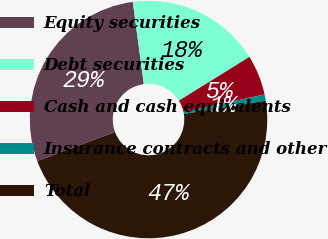<chart> <loc_0><loc_0><loc_500><loc_500><pie_chart><fcel>Equity securities<fcel>Debt securities<fcel>Cash and cash equivalents<fcel>Insurance contracts and other<fcel>Total<nl><fcel>28.57%<fcel>18.27%<fcel>5.46%<fcel>0.86%<fcel>46.84%<nl></chart> 